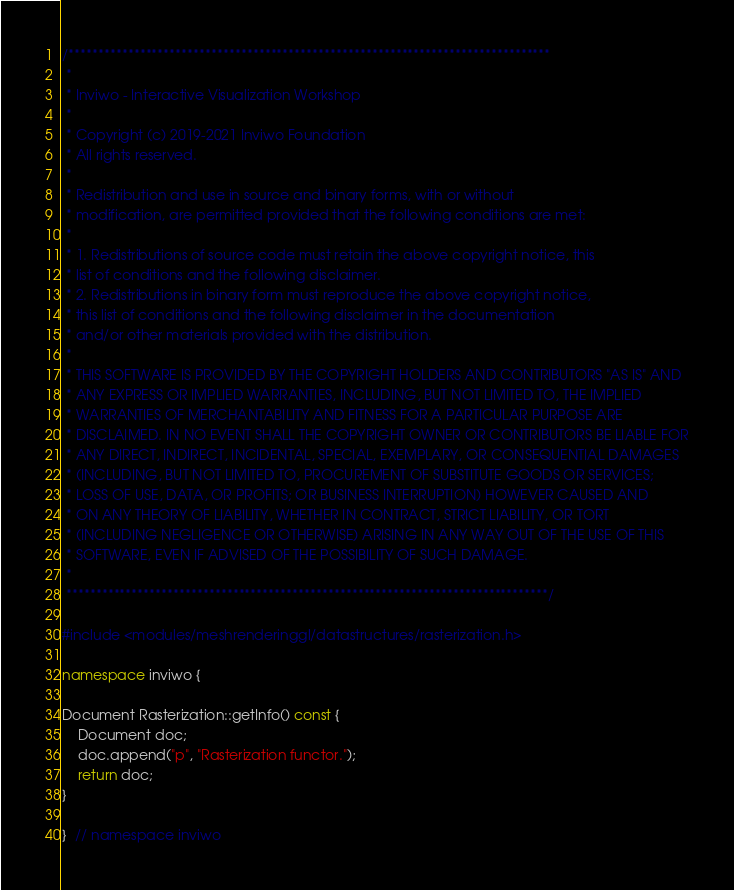<code> <loc_0><loc_0><loc_500><loc_500><_C++_>/*********************************************************************************
 *
 * Inviwo - Interactive Visualization Workshop
 *
 * Copyright (c) 2019-2021 Inviwo Foundation
 * All rights reserved.
 *
 * Redistribution and use in source and binary forms, with or without
 * modification, are permitted provided that the following conditions are met:
 *
 * 1. Redistributions of source code must retain the above copyright notice, this
 * list of conditions and the following disclaimer.
 * 2. Redistributions in binary form must reproduce the above copyright notice,
 * this list of conditions and the following disclaimer in the documentation
 * and/or other materials provided with the distribution.
 *
 * THIS SOFTWARE IS PROVIDED BY THE COPYRIGHT HOLDERS AND CONTRIBUTORS "AS IS" AND
 * ANY EXPRESS OR IMPLIED WARRANTIES, INCLUDING, BUT NOT LIMITED TO, THE IMPLIED
 * WARRANTIES OF MERCHANTABILITY AND FITNESS FOR A PARTICULAR PURPOSE ARE
 * DISCLAIMED. IN NO EVENT SHALL THE COPYRIGHT OWNER OR CONTRIBUTORS BE LIABLE FOR
 * ANY DIRECT, INDIRECT, INCIDENTAL, SPECIAL, EXEMPLARY, OR CONSEQUENTIAL DAMAGES
 * (INCLUDING, BUT NOT LIMITED TO, PROCUREMENT OF SUBSTITUTE GOODS OR SERVICES;
 * LOSS OF USE, DATA, OR PROFITS; OR BUSINESS INTERRUPTION) HOWEVER CAUSED AND
 * ON ANY THEORY OF LIABILITY, WHETHER IN CONTRACT, STRICT LIABILITY, OR TORT
 * (INCLUDING NEGLIGENCE OR OTHERWISE) ARISING IN ANY WAY OUT OF THE USE OF THIS
 * SOFTWARE, EVEN IF ADVISED OF THE POSSIBILITY OF SUCH DAMAGE.
 *
 *********************************************************************************/

#include <modules/meshrenderinggl/datastructures/rasterization.h>

namespace inviwo {

Document Rasterization::getInfo() const {
    Document doc;
    doc.append("p", "Rasterization functor.");
    return doc;
}

}  // namespace inviwo</code> 